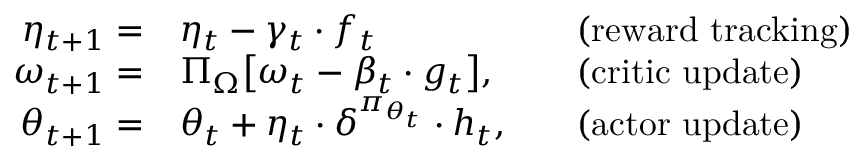Convert formula to latex. <formula><loc_0><loc_0><loc_500><loc_500>\begin{array} { r l r l } { \eta _ { t + 1 } = } & { \eta _ { t } - \gamma _ { t } \cdot f _ { t } } & & { ( r e w a r d t r a c k i n g ) } \\ { \omega _ { t + 1 } = } & { \Pi _ { \Omega } \left [ \omega _ { t } - \beta _ { t } \cdot g _ { t } \right ] , } & & { ( c r i t i c u p d a t e ) } \\ { \theta _ { t + 1 } = } & { \theta _ { t } + \eta _ { t } \cdot \delta ^ { \pi _ { \theta _ { t } } } \cdot h _ { t } , } & & { ( a c t o r u p d a t e ) } \end{array}</formula> 